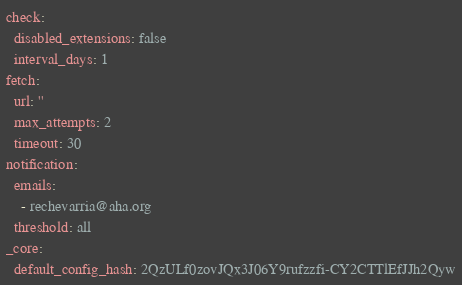Convert code to text. <code><loc_0><loc_0><loc_500><loc_500><_YAML_>check:
  disabled_extensions: false
  interval_days: 1
fetch:
  url: ''
  max_attempts: 2
  timeout: 30
notification:
  emails:
    - rechevarria@aha.org
  threshold: all
_core:
  default_config_hash: 2QzULf0zovJQx3J06Y9rufzzfi-CY2CTTlEfJJh2Qyw
</code> 